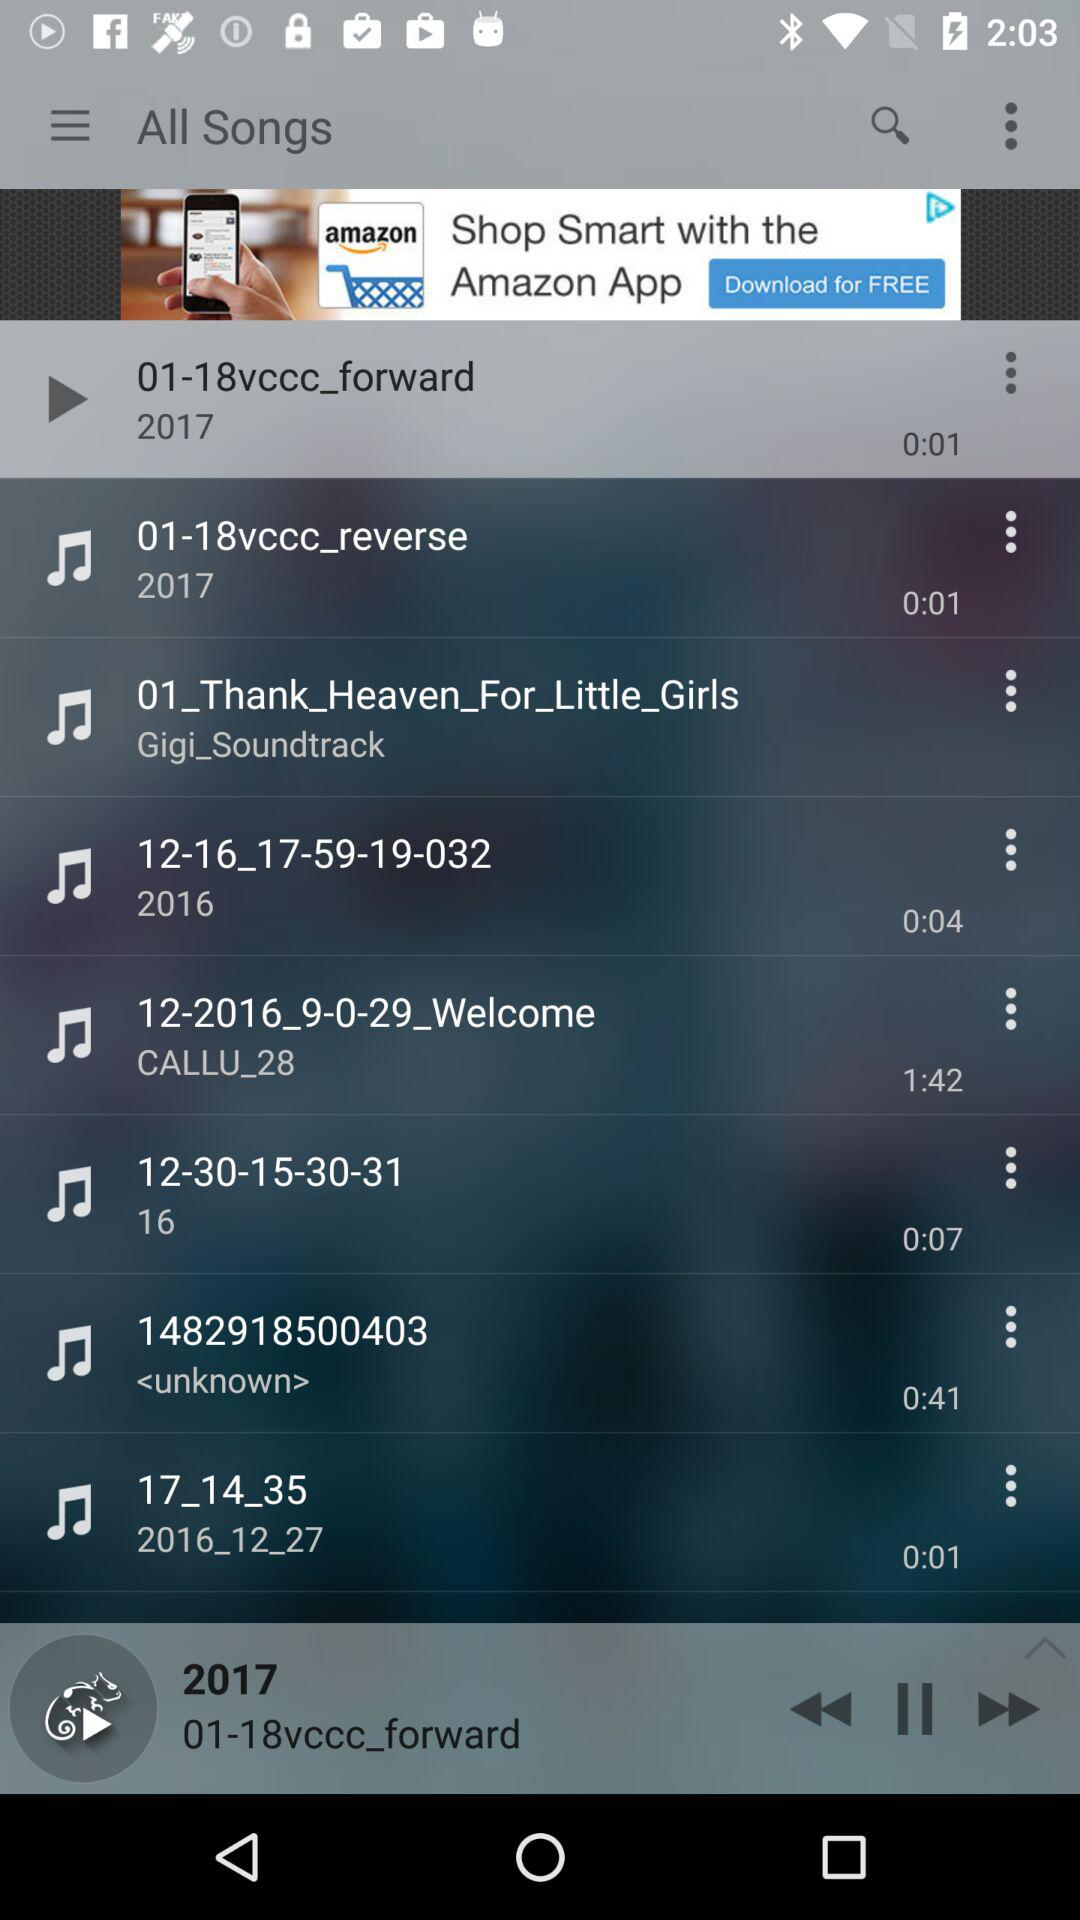What is the total length of the audio, ending with "403"? The total length of the audio is 0:41. 